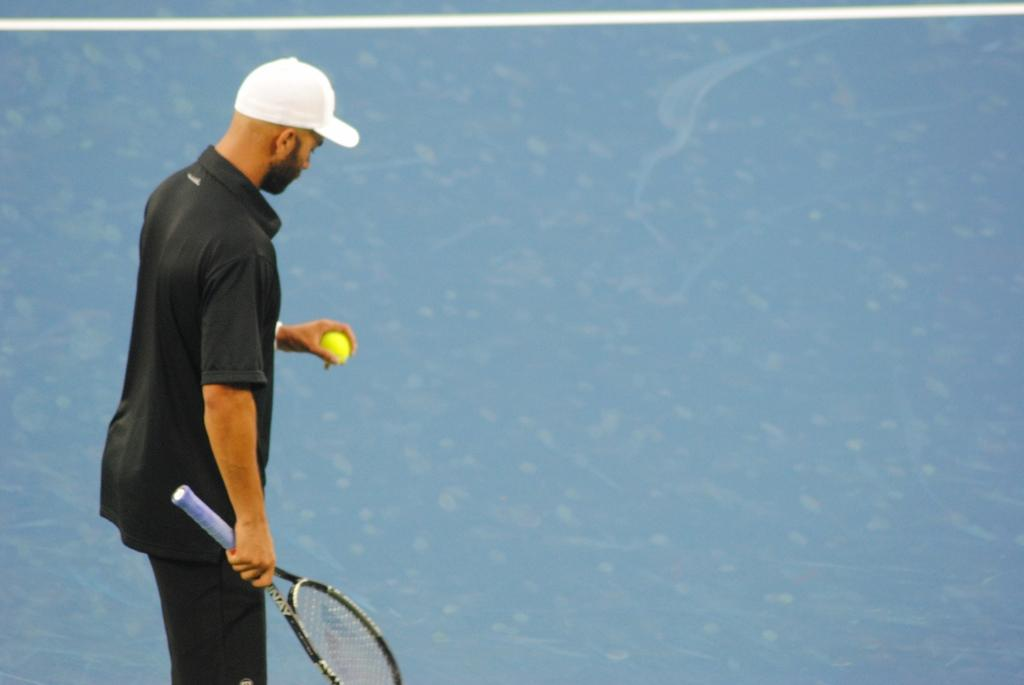What is the main subject of the image? The main subject of the image is a man. What is the man wearing on his head? The man is wearing a cap. What objects is the man holding in the image? The man is holding a ball and a bat. What type of picture is hanging on the wall behind the man in the image? There is no information about a picture hanging on the wall behind the man in the image. Can you tell me how many quinces are on the table next to the man? There is no table or quinces present in the image. 